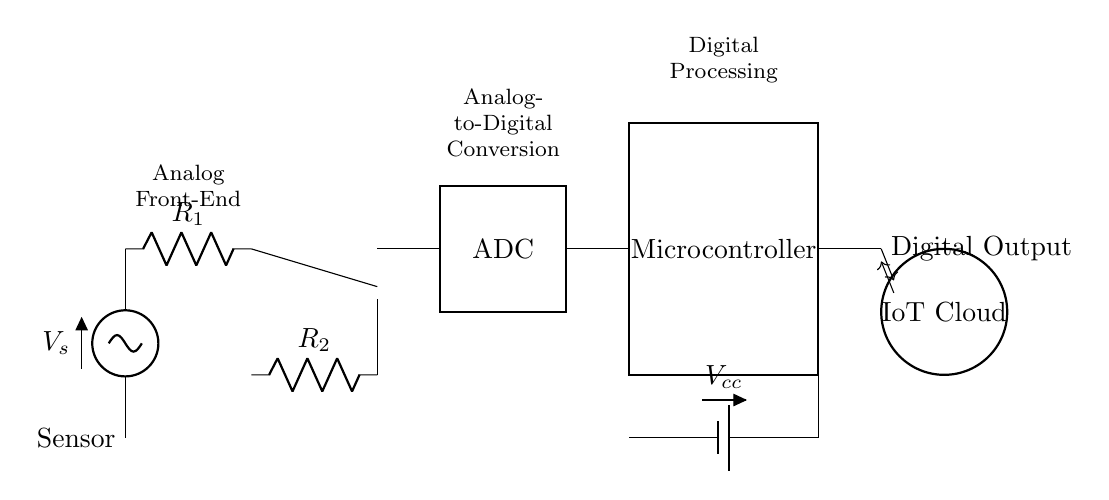What is the function of the component labeled "ADC"? The ADC, or Analog-to-Digital Converter, transforms analog signals from the sensor into a digital format for processing. This is vital for enabling microcontrollers to interpret sensor data.
Answer: Analog-to-Digital Converter What supplies power to the circuit? The power supply is indicated by the battery symbol labeled "Vcc," which provides necessary voltage for the components in the circuit.
Answer: Vcc How many resistors are present in the circuit? The circuit diagram shows two resistors labeled "R1" and "R2," which are components that limit current or divide voltage in the analog front-end.
Answer: Two What is the output type from the microcontroller? The output from the microcontroller is a digital signal, as indicated by the label "Digital Output," which represents processed data sent to the IoT Cloud.
Answer: Digital Output Why is the operational amplifier used in the circuit? The operational amplifier amplifies the signals from the analog front-end (R2) to enhance the sensor's output for more effective digital conversion, especially in low-signal applications.
Answer: Signal amplification What role does the IoT Cloud play in this circuit? The IoT Cloud receives the processed digital signals from the microcontroller, which allows for remote monitoring and interaction with the system, enabling IoT functionalities.
Answer: Remote monitoring 